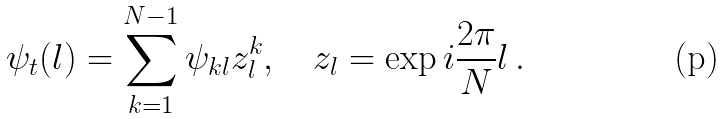<formula> <loc_0><loc_0><loc_500><loc_500>\psi _ { t } ( l ) = \sum _ { k = 1 } ^ { N - 1 } \psi _ { k l } z _ { l } ^ { k } , \quad z _ { l } = \exp i \frac { 2 \pi } { N } l \, .</formula> 